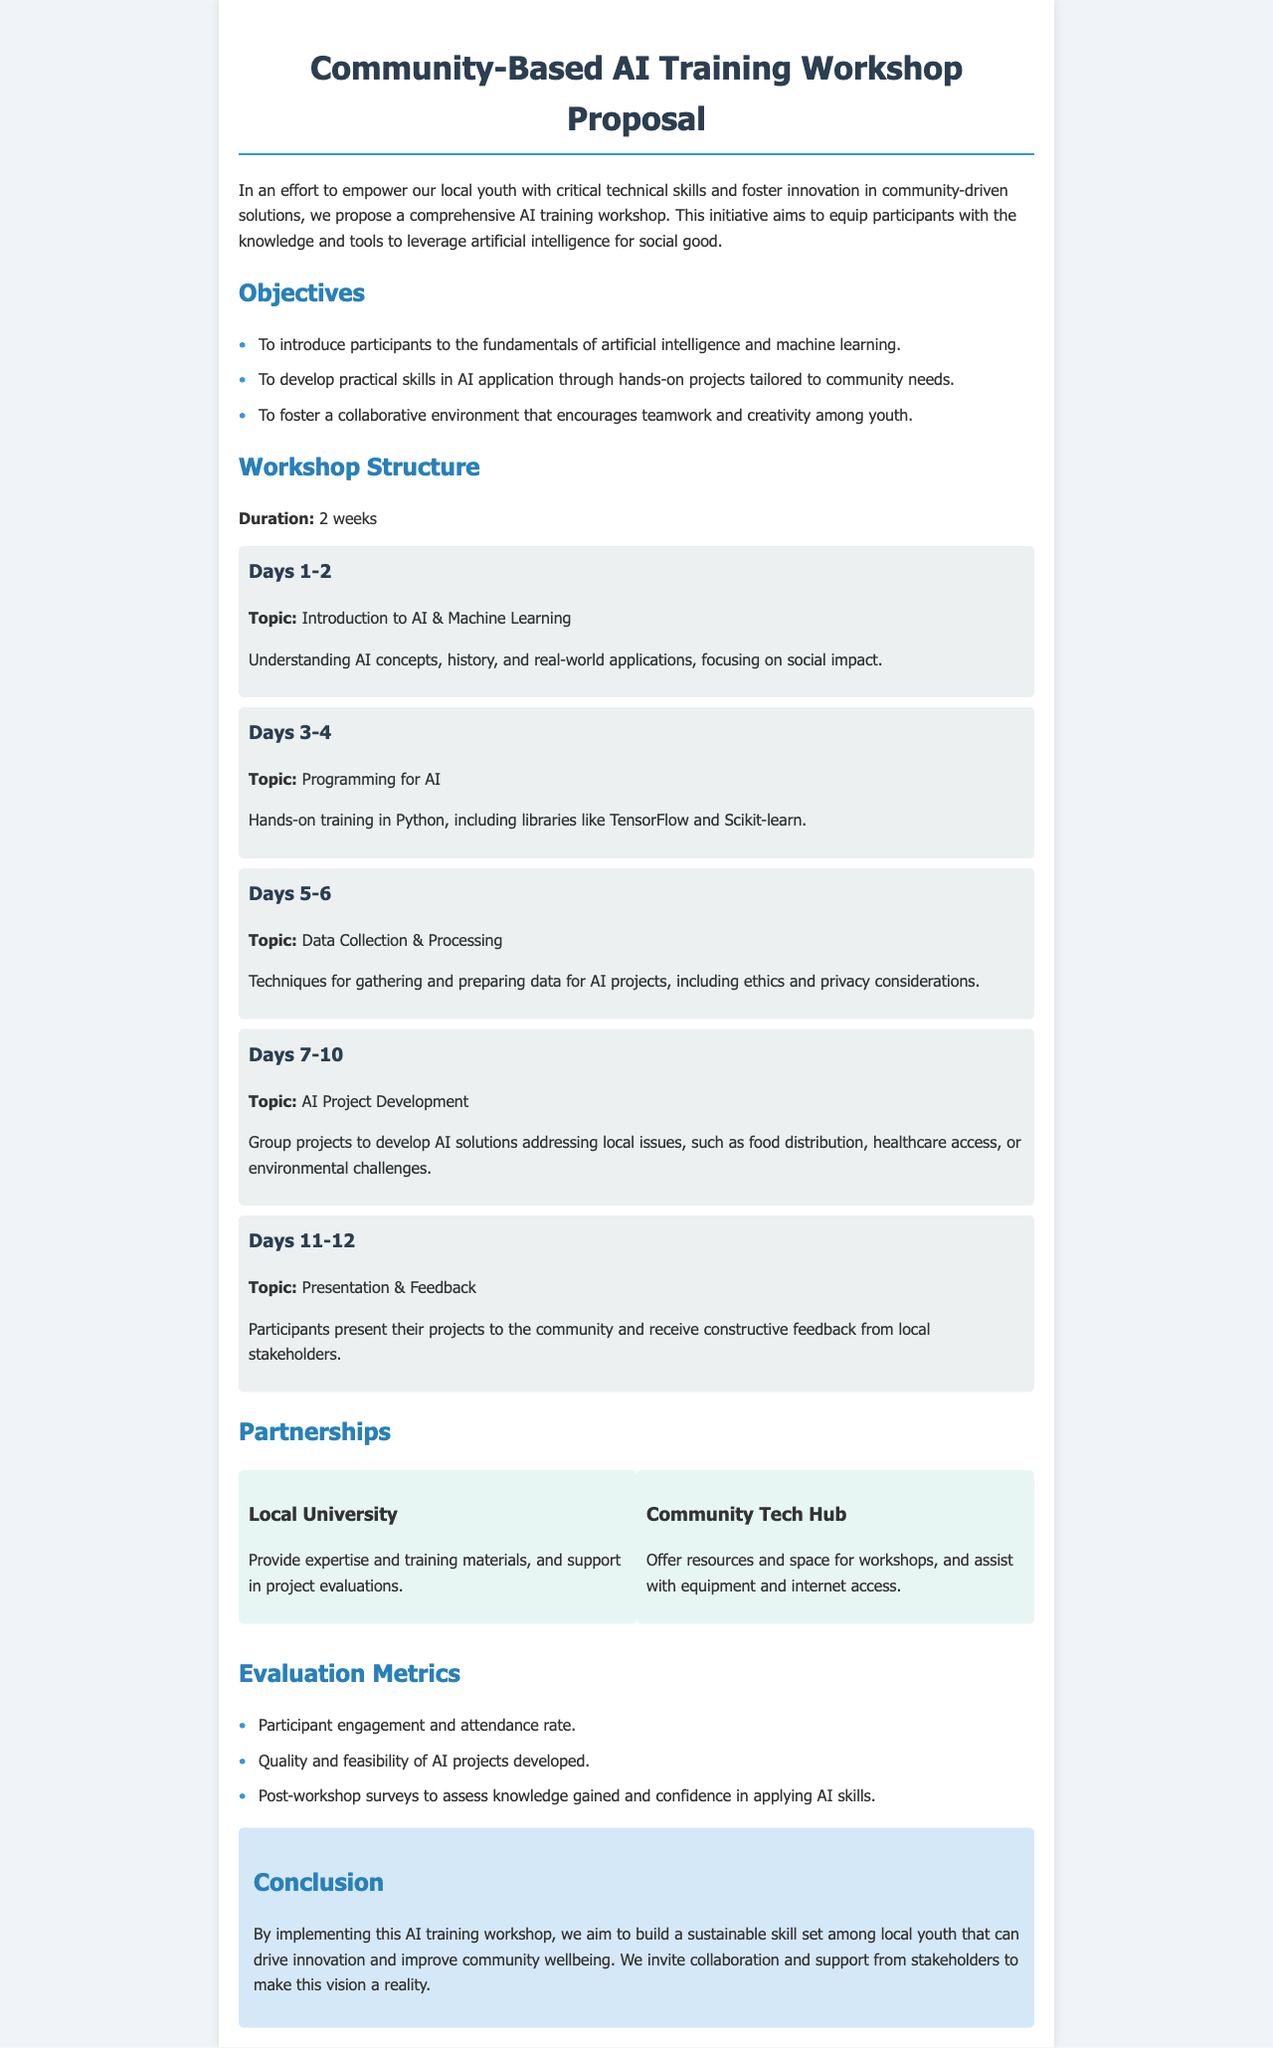what is the duration of the workshop? The duration of the workshop is specified in the document, which states it will last for 2 weeks.
Answer: 2 weeks what is one of the objectives of the workshop? The document lists objectives of the workshop, one of which is to introduce participants to the fundamentals of artificial intelligence and machine learning.
Answer: Introduce participants to the fundamentals of artificial intelligence and machine learning how many days are dedicated to AI Project Development? The document outlines that group projects to develop AI solutions will take place over Days 7-10.
Answer: 4 days what is the name of one partner organization involved? The document specifies partner organizations that will assist with the workshop; one of them is Local University.
Answer: Local University what type of evaluation metric will be used? Among the evaluation metrics listed, the document states that participant engagement and attendance rate will be assessed.
Answer: Participant engagement and attendance rate which programming language will be taught during the workshop? The document indicates that hands-on training will be provided in Python, which is a programming language essential for AI applications.
Answer: Python what is the purpose of the feedback session? The document states that participants present their projects to the community and receive constructive feedback from local stakeholders, which aims to enhance learning and improvement.
Answer: Receive constructive feedback from local stakeholders what kind of environment is the workshop aiming to foster? The workshop aims to foster a collaborative environment that encourages teamwork and creativity among youth, as outlined in the objectives.
Answer: Collaborative environment 